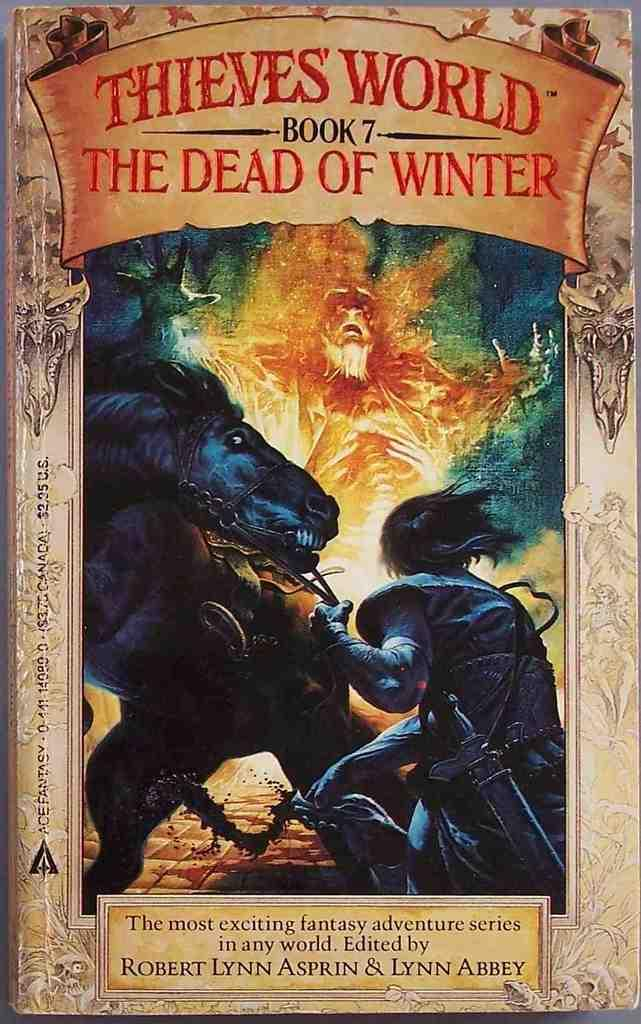<image>
Give a short and clear explanation of the subsequent image. Poster showing a man handling a horse titled "Thieves World". 